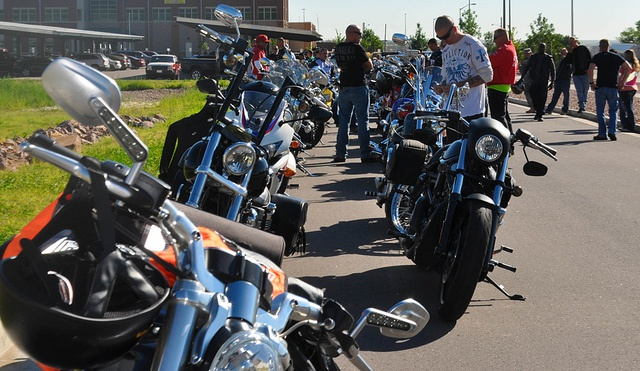Describe the objects in this image and their specific colors. I can see motorcycle in gray, black, darkgray, and lightgray tones, motorcycle in gray, black, darkgray, and lightgray tones, motorcycle in gray, black, darkgray, and navy tones, motorcycle in gray, black, navy, and blue tones, and people in gray, black, and maroon tones in this image. 